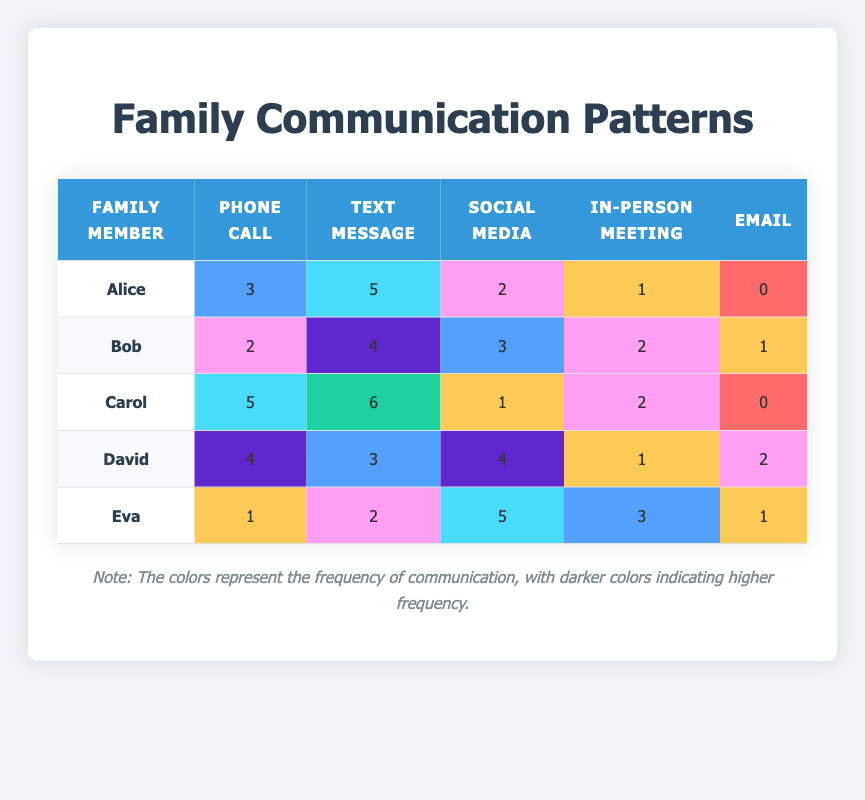What is the highest frequency of communication for Alice? In the table, Alice's frequencies for each communication method are: Phone Call (3), Text Message (5), Social Media (2), In-Person Meeting (1), Email (0). The highest frequency is 5 for Text Message.
Answer: 5 How many times did Bob use Email? Referring to Bob's row in the table, the frequency for Email is 1.
Answer: 1 What is the total frequency of communication methods used by David? David's frequencies are: Phone Call (4), Text Message (3), Social Media (4), In-Person Meeting (1), Email (2). Adding them gives 4 + 3 + 4 + 1 + 2 = 14.
Answer: 14 Which family member has the least frequency of communication via Social Media? The frequencies for Social Media are: Alice (2), Bob (3), Carol (1), David (4), Eva (5). The least frequency is 1, which belongs to Carol.
Answer: Carol Is Eva's preferred communication method In-Person Meeting? Eva's frequencies are: Phone Call (1), Text Message (2), Social Media (5), In-Person Meeting (3), Email (1). The highest frequency is 5 for Social Media, not In-Person Meeting. Therefore, this statement is false.
Answer: No How does Carol's usage of Text Messaging compare to David's usage of Text Messaging? Carol's frequency for Text Messages is 6, while David's is 3. Comparing the two: 6 - 3 = 3, meaning Carol uses Text Messaging 3 times more than David.
Answer: Carol uses it 3 times more What is the average frequency of communication methods across all family members for Email? Summing the frequencies of Email for all family members: Alice (0), Bob (1), Carol (0), David (2), Eva (1) gives 0 + 1 + 0 + 2 + 1 = 4. There are 5 family members, so the average is 4/5 = 0.8.
Answer: 0.8 Which family member communicates the most frequently in general? To determine this, we calculate the total frequencies for each member: Alice (3+5+2+1+0=11), Bob (2+4+3+2+1=12), Carol (5+6+1+2+0=14), David (4+3+4+1+2=14), Eva (1+2+5+3+1=12). The highest frequency is 14, shared by Carol and David.
Answer: Carol and David Which communication method has the highest frequency overall across all family members? Summing frequencies for each method: Phone Call (3+2+5+4+1=15), Text Message (5+4+6+3+2=20), Social Media (2+3+1+4+5=15), In-Person Meeting (1+2+2+1+3=9), Email (0+1+0+2+1=4). Text Message has the highest total of 20.
Answer: Text Message 